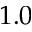Convert formula to latex. <formula><loc_0><loc_0><loc_500><loc_500>1 . 0</formula> 